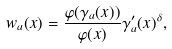<formula> <loc_0><loc_0><loc_500><loc_500>w _ { a } ( x ) = \frac { \varphi ( \gamma _ { a } ( x ) ) } { \varphi ( x ) } \gamma _ { a } ^ { \prime } ( x ) ^ { \delta } ,</formula> 